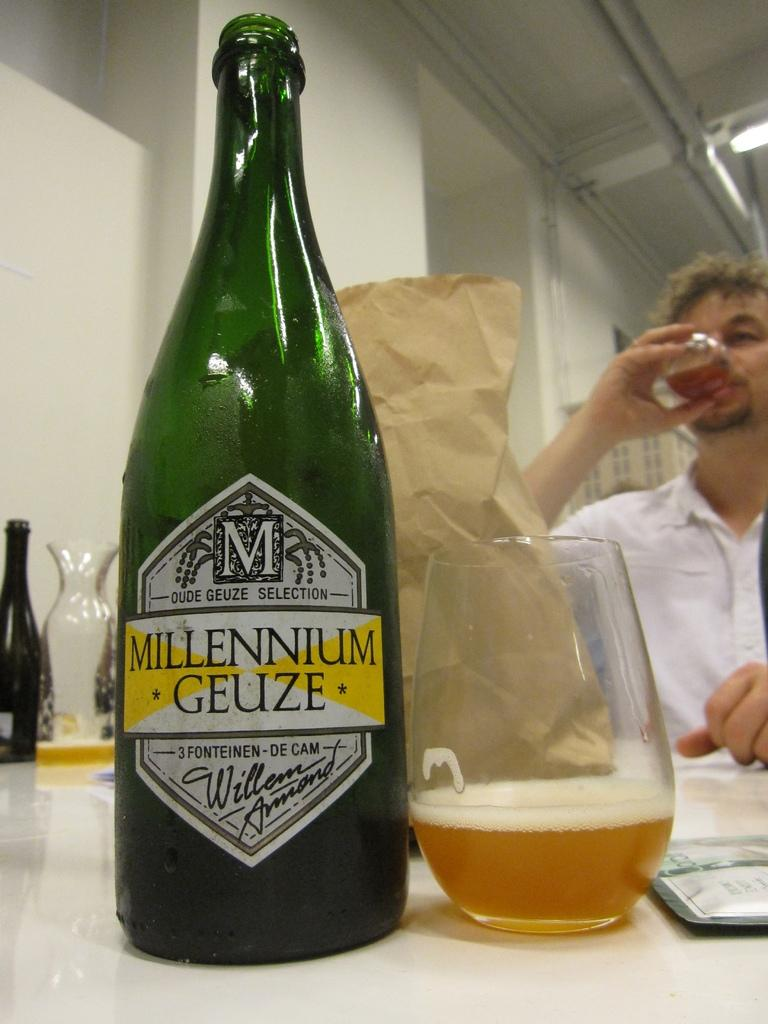What is one object visible in the image? There is a bottle in the image. What else can be seen in the image? There is a glass in the image. What is the man in the image doing with the glass? A man is holding a glass in the image. How is the man dressed in the image? The man is wearing a white shirt. Are there any other bottles visible in the image? Yes, there is another bottle in the image. What type of bulb is being used by the man in the image? There is no bulb present in the image. Is there a representative of a company in the image? The provided facts do not mention any representatives or companies, so it cannot be determined from the image. 